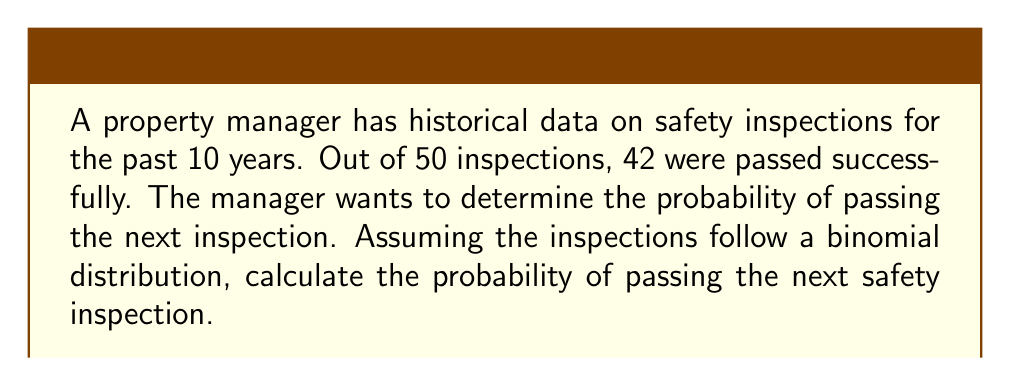Can you answer this question? To solve this problem, we'll use the concept of maximum likelihood estimation (MLE) on a manifold, specifically the probability simplex.

1) Let $p$ be the probability of passing an inspection. The likelihood function for a binomial distribution is:

   $$L(p) = \binom{n}{k} p^k (1-p)^{n-k}$$

   where $n$ is the total number of trials and $k$ is the number of successes.

2) In this case, $n = 50$ and $k = 42$. The log-likelihood function is:

   $$\ell(p) = \log L(p) = \log \binom{50}{42} + 42 \log p + 8 \log (1-p)$$

3) The MLE of $p$ is the value that maximizes $\ell(p)$. On the probability simplex (a 1-dimensional manifold in this case), the MLE is simply:

   $$\hat{p} = \frac{k}{n} = \frac{42}{50} = 0.84$$

4) This estimate $\hat{p}$ is our best guess for the probability of passing future inspections, based on the historical data.

5) The probability simplex for a binomial distribution is the interval $[0,1]$, and our estimate lies within this manifold.

6) To assess the uncertainty of our estimate, we can compute the Fisher information:

   $$I(p) = \frac{n}{p(1-p)}$$

   At $\hat{p} = 0.84$, $I(0.84) \approx 328.125$

7) The inverse of the Fisher information gives us the asymptotic variance of our estimator:

   $$\text{Var}(\hat{p}) \approx \frac{1}{328.125} \approx 0.003$$

8) This low variance indicates that our estimate is relatively precise.

Therefore, based on the historical data and assuming the conditions remain similar, the probability of passing the next safety inspection is approximately 0.84 or 84%.
Answer: The probability of passing the next safety inspection is approximately 0.84 or 84%. 